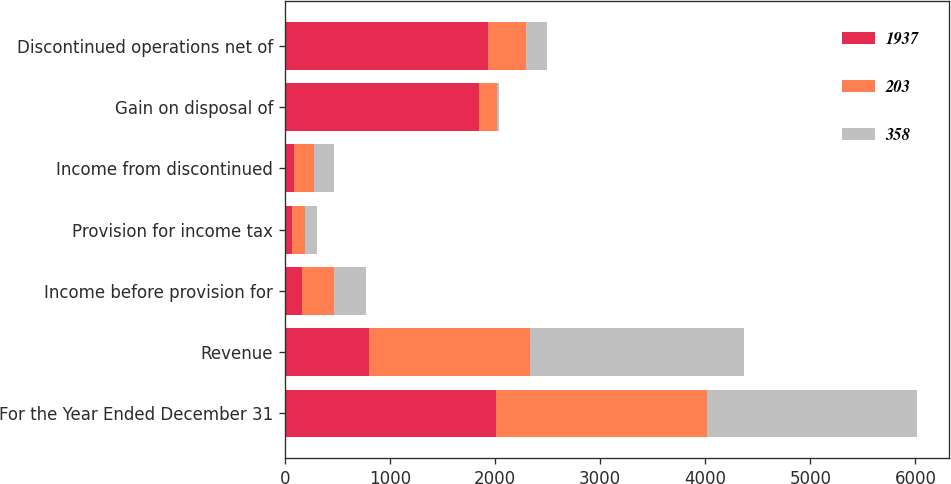<chart> <loc_0><loc_0><loc_500><loc_500><stacked_bar_chart><ecel><fcel>For the Year Ended December 31<fcel>Revenue<fcel>Income before provision for<fcel>Provision for income tax<fcel>Income from discontinued<fcel>Gain on disposal of<fcel>Discontinued operations net of<nl><fcel>1937<fcel>2007<fcel>798<fcel>160<fcel>71<fcel>89<fcel>1848<fcel>1937<nl><fcel>203<fcel>2006<fcel>1533<fcel>304<fcel>118<fcel>186<fcel>172<fcel>358<nl><fcel>358<fcel>2005<fcel>2037<fcel>306<fcel>117<fcel>189<fcel>14<fcel>203<nl></chart> 